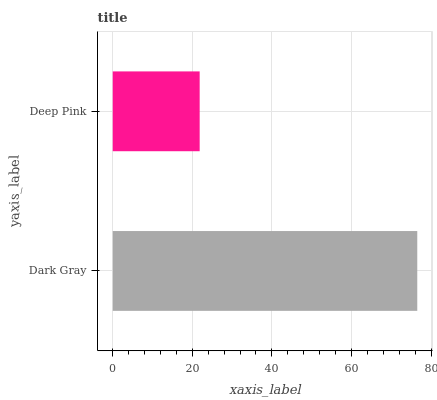Is Deep Pink the minimum?
Answer yes or no. Yes. Is Dark Gray the maximum?
Answer yes or no. Yes. Is Deep Pink the maximum?
Answer yes or no. No. Is Dark Gray greater than Deep Pink?
Answer yes or no. Yes. Is Deep Pink less than Dark Gray?
Answer yes or no. Yes. Is Deep Pink greater than Dark Gray?
Answer yes or no. No. Is Dark Gray less than Deep Pink?
Answer yes or no. No. Is Dark Gray the high median?
Answer yes or no. Yes. Is Deep Pink the low median?
Answer yes or no. Yes. Is Deep Pink the high median?
Answer yes or no. No. Is Dark Gray the low median?
Answer yes or no. No. 